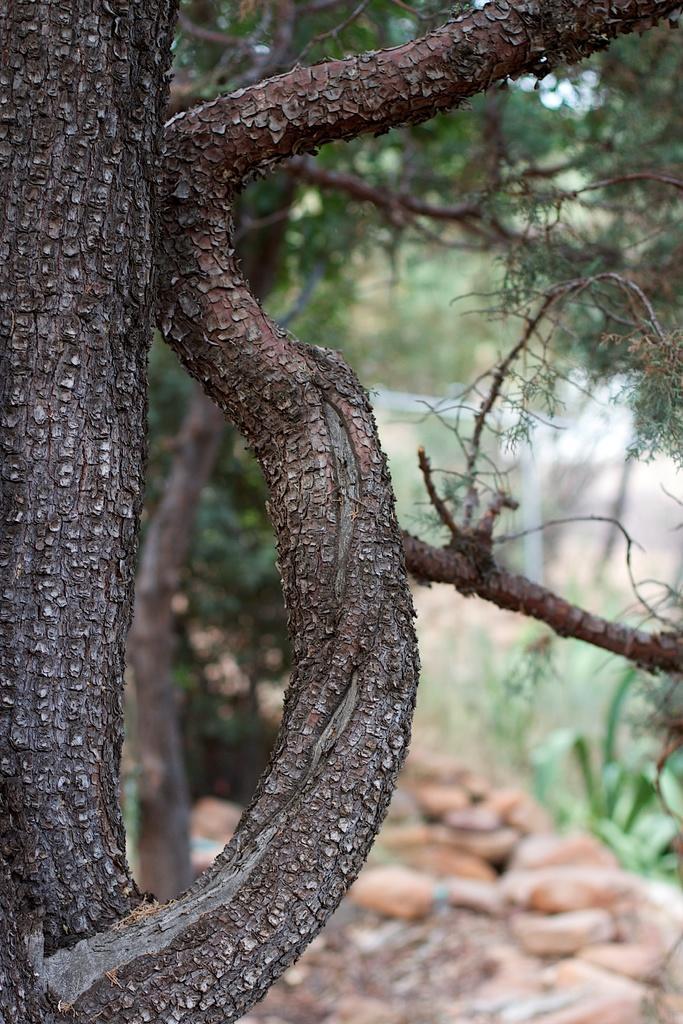In one or two sentences, can you explain what this image depicts? In this image I can see tree trunk and branches. Also there is a tree, there are stones and the background is blurry. 